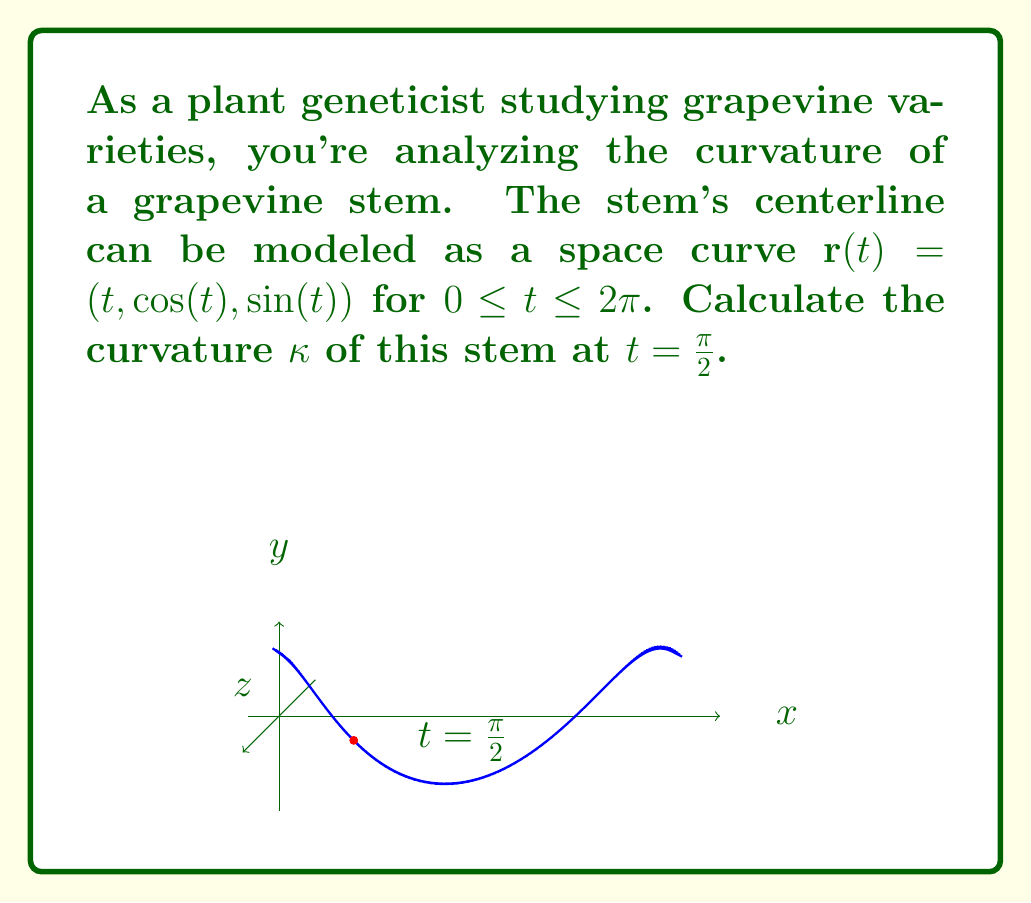Can you answer this question? To calculate the curvature of the space curve, we'll follow these steps:

1) The curvature $\kappa$ is given by the formula:

   $$\kappa = \frac{|\mathbf{r}'(t) \times \mathbf{r}''(t)|}{|\mathbf{r}'(t)|^3}$$

2) First, let's calculate $\mathbf{r}'(t)$:
   $$\mathbf{r}'(t) = (1, -\sin(t), \cos(t))$$

3) Then, calculate $\mathbf{r}''(t)$:
   $$\mathbf{r}''(t) = (0, -\cos(t), -\sin(t))$$

4) Now, we need to calculate the cross product $\mathbf{r}'(t) \times \mathbf{r}''(t)$:
   $$\mathbf{r}'(t) \times \mathbf{r}''(t) = \begin{vmatrix}
   \mathbf{i} & \mathbf{j} & \mathbf{k} \\
   1 & -\sin(t) & \cos(t) \\
   0 & -\cos(t) & -\sin(t)
   \end{vmatrix}$$
   
   $$= (\sin^2(t) + \cos^2(t))\mathbf{i} + \cos(t)\mathbf{j} + \sin(t)\mathbf{k}$$
   
   $$= \mathbf{i} + \cos(t)\mathbf{j} + \sin(t)\mathbf{k}$$

5) The magnitude of this cross product is:
   $$|\mathbf{r}'(t) \times \mathbf{r}''(t)| = \sqrt{1 + \cos^2(t) + \sin^2(t)} = \sqrt{2}$$

6) Next, we calculate $|\mathbf{r}'(t)|$:
   $$|\mathbf{r}'(t)| = \sqrt{1 + \sin^2(t) + \cos^2(t)} = \sqrt{2}$$

7) Now we can substitute these into our curvature formula:
   $$\kappa = \frac{\sqrt{2}}{(\sqrt{2})^3} = \frac{\sqrt{2}}{2\sqrt{2}} = \frac{1}{2}$$

8) This result is constant for all $t$, including $t = \frac{\pi}{2}$.

Therefore, the curvature of the grapevine stem at $t = \frac{\pi}{2}$ (and indeed at all points) is $\frac{1}{2}$.
Answer: $\frac{1}{2}$ 